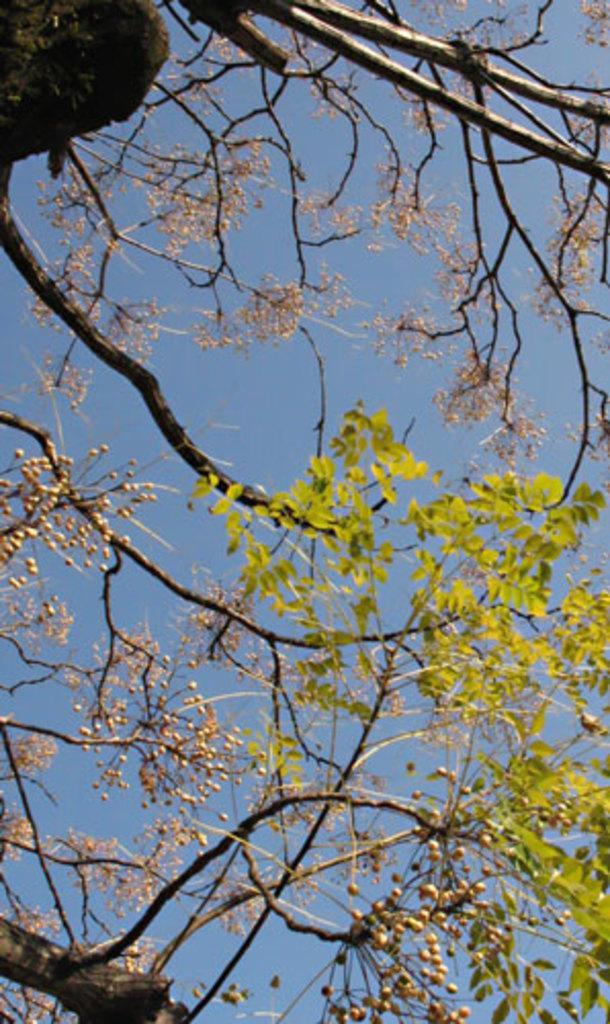Can you describe this image briefly? In this image we can see a tree and sky. 